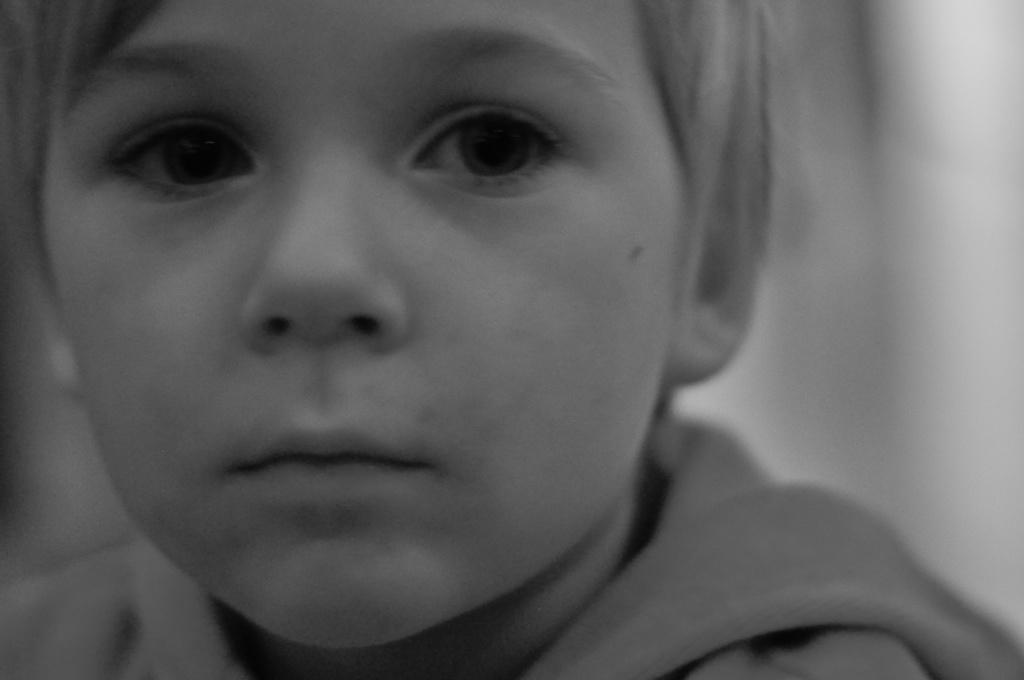What is the main subject of the image? There is a small boy in the image. Can you describe the boy in the image? The provided facts do not include any details about the boy's appearance or clothing. What might the boy be doing in the image? The provided facts do not include any information about the boy's actions or activities. What type of plantation can be seen in the background of the image? There is no plantation present in the image; it features a small boy as the main subject. How many nuts are visible in the image? There are no nuts present in the image. 